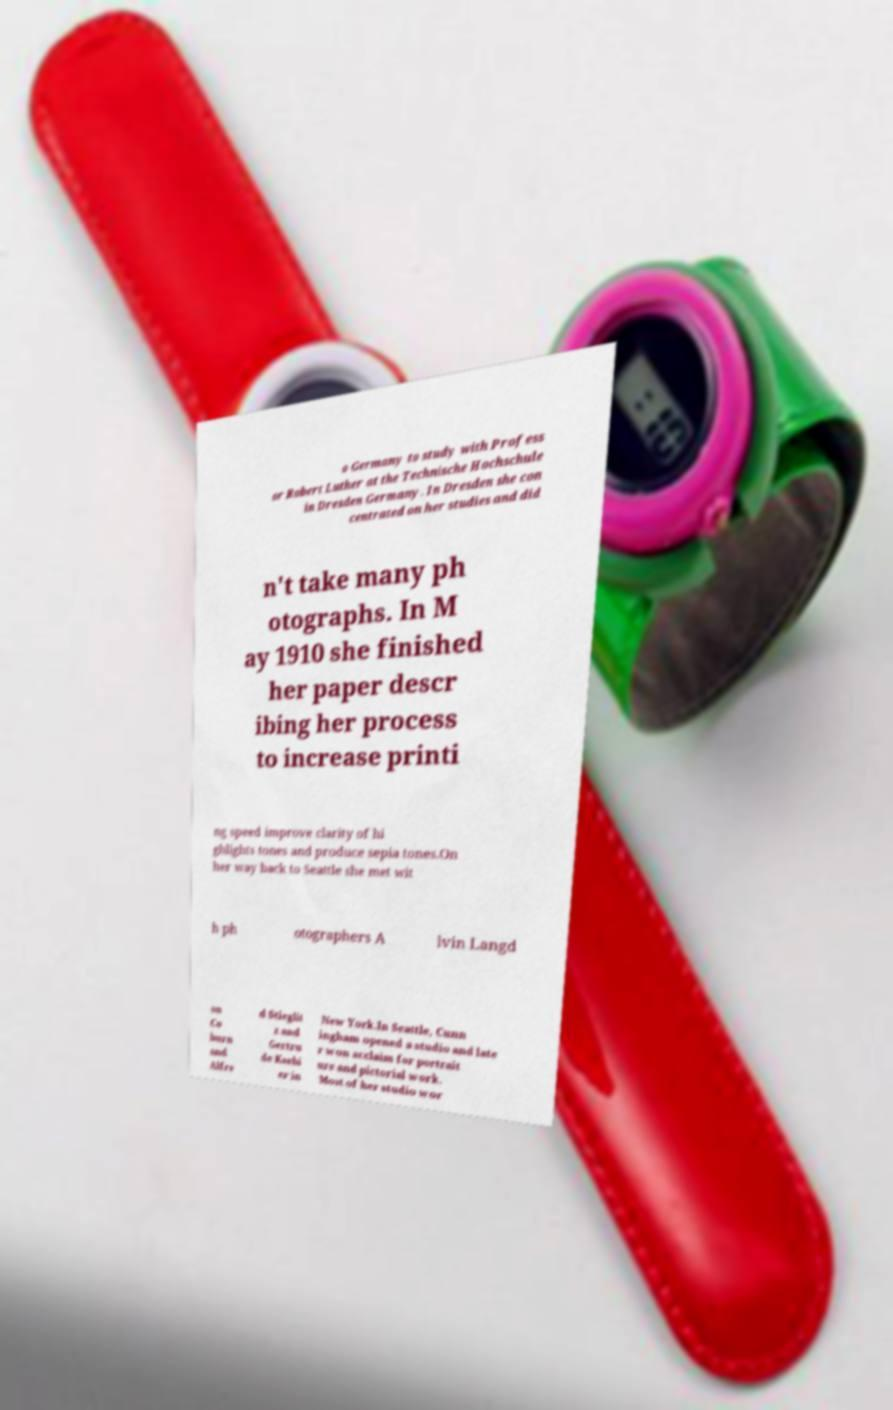I need the written content from this picture converted into text. Can you do that? o Germany to study with Profess or Robert Luther at the Technische Hochschule in Dresden Germany. In Dresden she con centrated on her studies and did n't take many ph otographs. In M ay 1910 she finished her paper descr ibing her process to increase printi ng speed improve clarity of hi ghlights tones and produce sepia tones.On her way back to Seattle she met wit h ph otographers A lvin Langd on Co burn and Alfre d Stieglit z and Gertru de Ksebi er in New York.In Seattle, Cunn ingham opened a studio and late r won acclaim for portrait ure and pictorial work. Most of her studio wor 